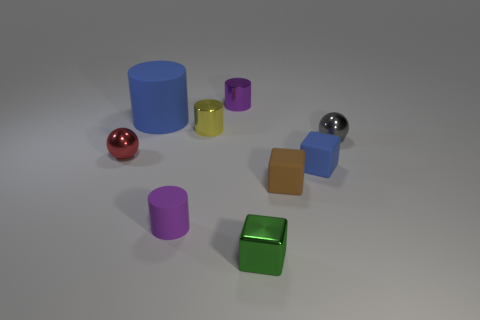Are there more big purple blocks than tiny purple matte objects?
Your answer should be very brief. No. What number of objects are both to the left of the small yellow object and behind the tiny red ball?
Offer a very short reply. 1. There is a small metallic sphere to the left of the gray metal sphere; what number of tiny purple objects are in front of it?
Offer a very short reply. 1. There is a blue thing that is behind the gray metal object; is its size the same as the rubber cylinder that is in front of the yellow thing?
Keep it short and to the point. No. How many tiny purple metallic spheres are there?
Your answer should be very brief. 0. How many red spheres have the same material as the green object?
Ensure brevity in your answer.  1. Are there the same number of matte blocks that are to the left of the large blue rubber cylinder and red metal objects?
Offer a very short reply. No. There is a thing that is the same color as the small matte cylinder; what material is it?
Give a very brief answer. Metal. There is a brown block; is it the same size as the purple cylinder in front of the tiny brown matte thing?
Offer a very short reply. Yes. What number of other objects are there of the same size as the yellow thing?
Your answer should be compact. 7. 